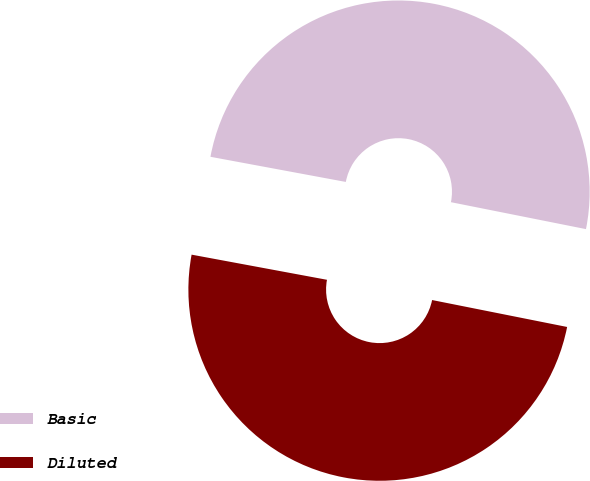Convert chart. <chart><loc_0><loc_0><loc_500><loc_500><pie_chart><fcel>Basic<fcel>Diluted<nl><fcel>50.21%<fcel>49.79%<nl></chart> 